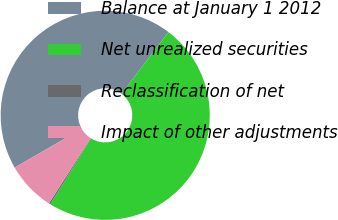Convert chart to OTSL. <chart><loc_0><loc_0><loc_500><loc_500><pie_chart><fcel>Balance at January 1 2012<fcel>Net unrealized securities<fcel>Reclassification of net<fcel>Impact of other adjustments<nl><fcel>43.68%<fcel>48.46%<fcel>0.25%<fcel>7.62%<nl></chart> 